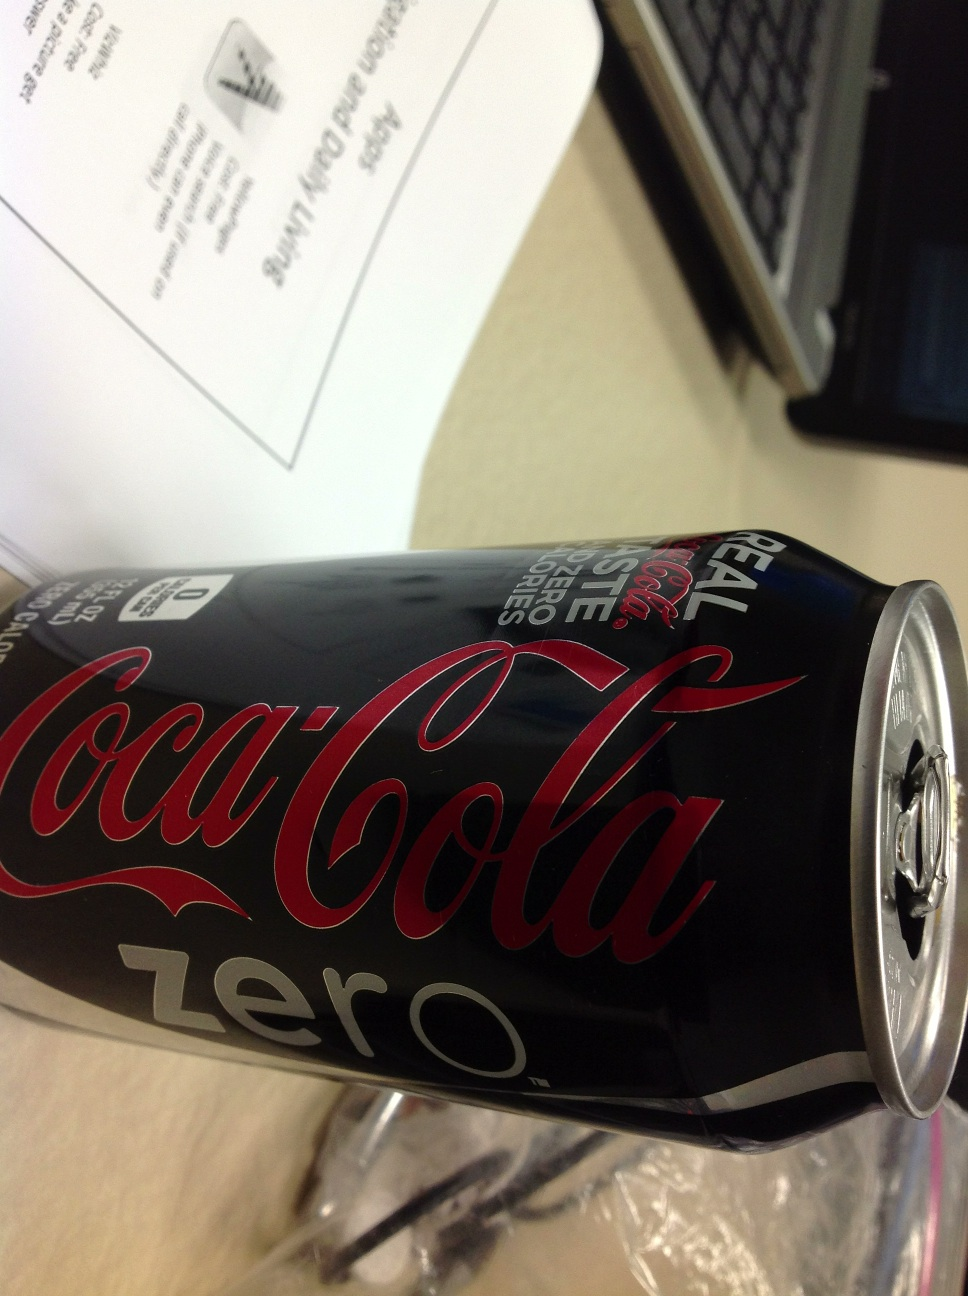What are some distinctive visual features of the product's branding? The can features a sleek black background with the iconic Coca-Cola script in red, emphasizing the word 'Zero' in white, which differentiates it from the regular Coca-Cola cans. The design is modern and targeted towards health-conscious consumers. 